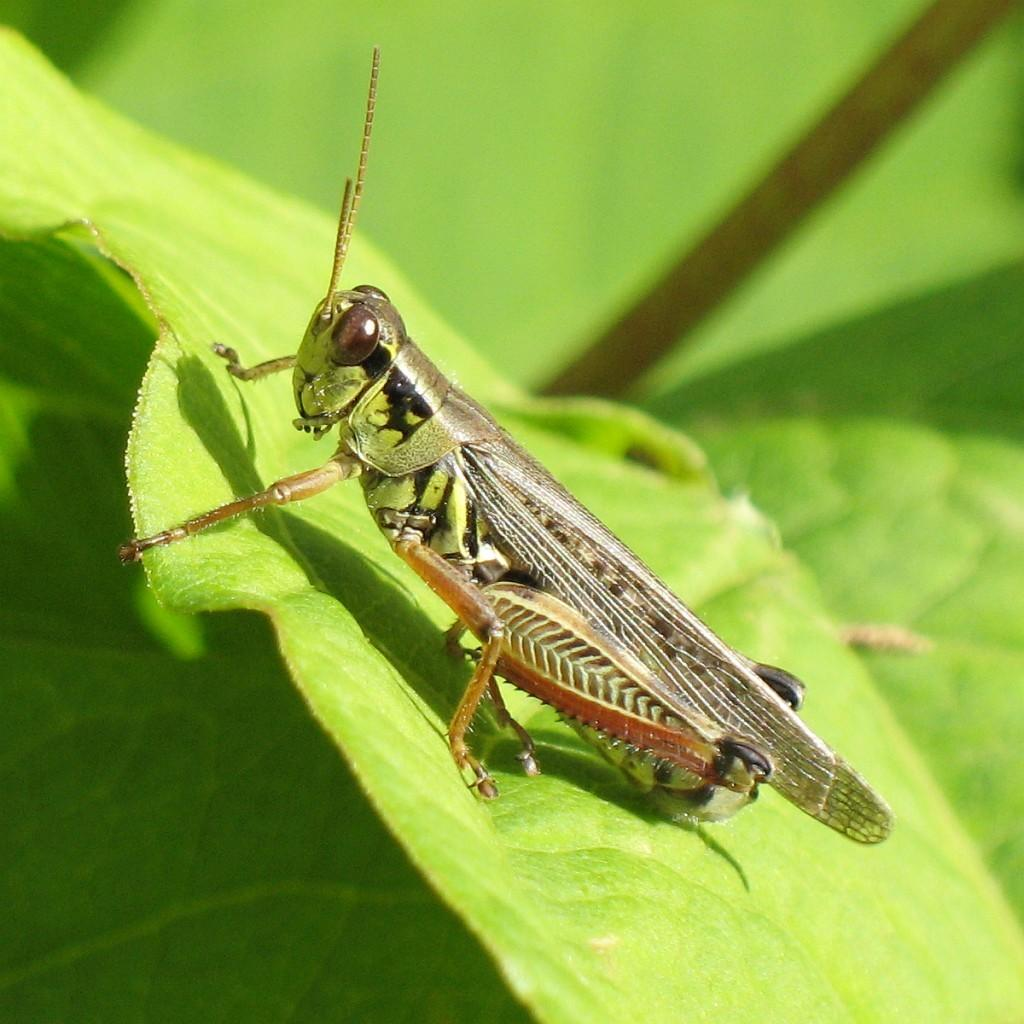What is present on the leaf in the image? There is an insect on the leaf in the image. What can be observed about the color of the leaves in the image? The leaves are green in color. What type of stage can be seen in the image? There is no stage present in the image; it features an insect on a leaf. How many balls are visible in the image? There are no balls present in the image. 